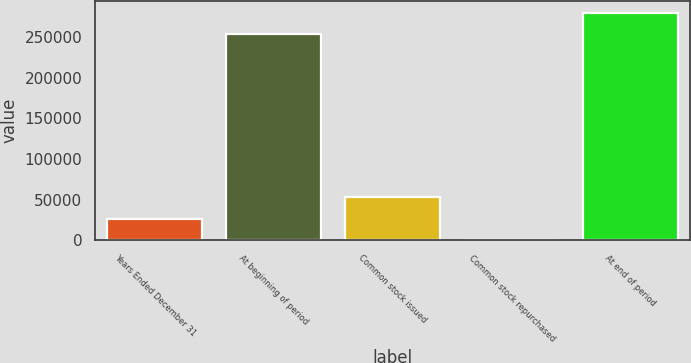<chart> <loc_0><loc_0><loc_500><loc_500><bar_chart><fcel>Years Ended December 31<fcel>At beginning of period<fcel>Common stock issued<fcel>Common stock repurchased<fcel>At end of period<nl><fcel>26757.3<fcel>254100<fcel>53125.6<fcel>389<fcel>280468<nl></chart> 